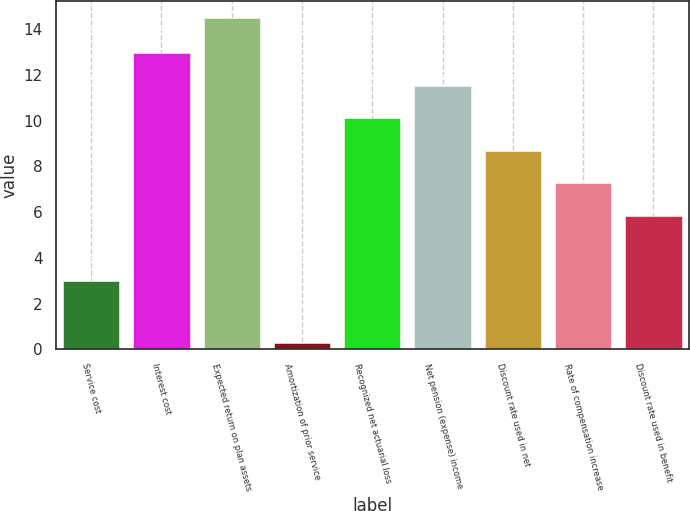Convert chart to OTSL. <chart><loc_0><loc_0><loc_500><loc_500><bar_chart><fcel>Service cost<fcel>Interest cost<fcel>Expected return on plan assets<fcel>Amortization of prior service<fcel>Recognized net actuarial loss<fcel>Net pension (expense) income<fcel>Discount rate used in net<fcel>Rate of compensation increase<fcel>Discount rate used in benefit<nl><fcel>3<fcel>12.94<fcel>14.5<fcel>0.3<fcel>10.1<fcel>11.52<fcel>8.68<fcel>7.26<fcel>5.84<nl></chart> 